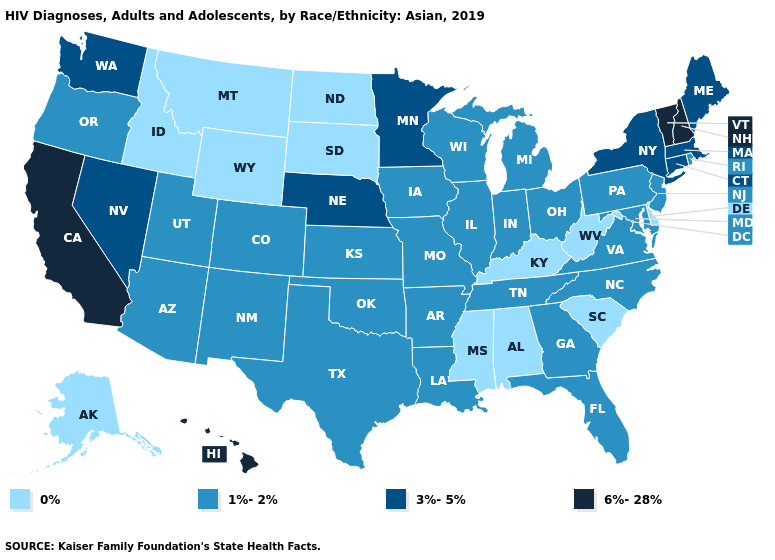Does Georgia have a higher value than Alabama?
Concise answer only. Yes. Does New Jersey have the lowest value in the Northeast?
Concise answer only. Yes. Does Nevada have the same value as Maine?
Answer briefly. Yes. Among the states that border Louisiana , which have the highest value?
Give a very brief answer. Arkansas, Texas. Which states have the lowest value in the Northeast?
Quick response, please. New Jersey, Pennsylvania, Rhode Island. Does New Hampshire have the highest value in the USA?
Concise answer only. Yes. What is the lowest value in the South?
Quick response, please. 0%. What is the lowest value in the West?
Short answer required. 0%. What is the value of Kansas?
Write a very short answer. 1%-2%. Among the states that border Louisiana , does Texas have the lowest value?
Write a very short answer. No. What is the value of Michigan?
Quick response, please. 1%-2%. Among the states that border North Carolina , which have the highest value?
Answer briefly. Georgia, Tennessee, Virginia. Name the states that have a value in the range 0%?
Quick response, please. Alabama, Alaska, Delaware, Idaho, Kentucky, Mississippi, Montana, North Dakota, South Carolina, South Dakota, West Virginia, Wyoming. Which states have the lowest value in the USA?
Be succinct. Alabama, Alaska, Delaware, Idaho, Kentucky, Mississippi, Montana, North Dakota, South Carolina, South Dakota, West Virginia, Wyoming. Among the states that border Connecticut , does Massachusetts have the highest value?
Give a very brief answer. Yes. 